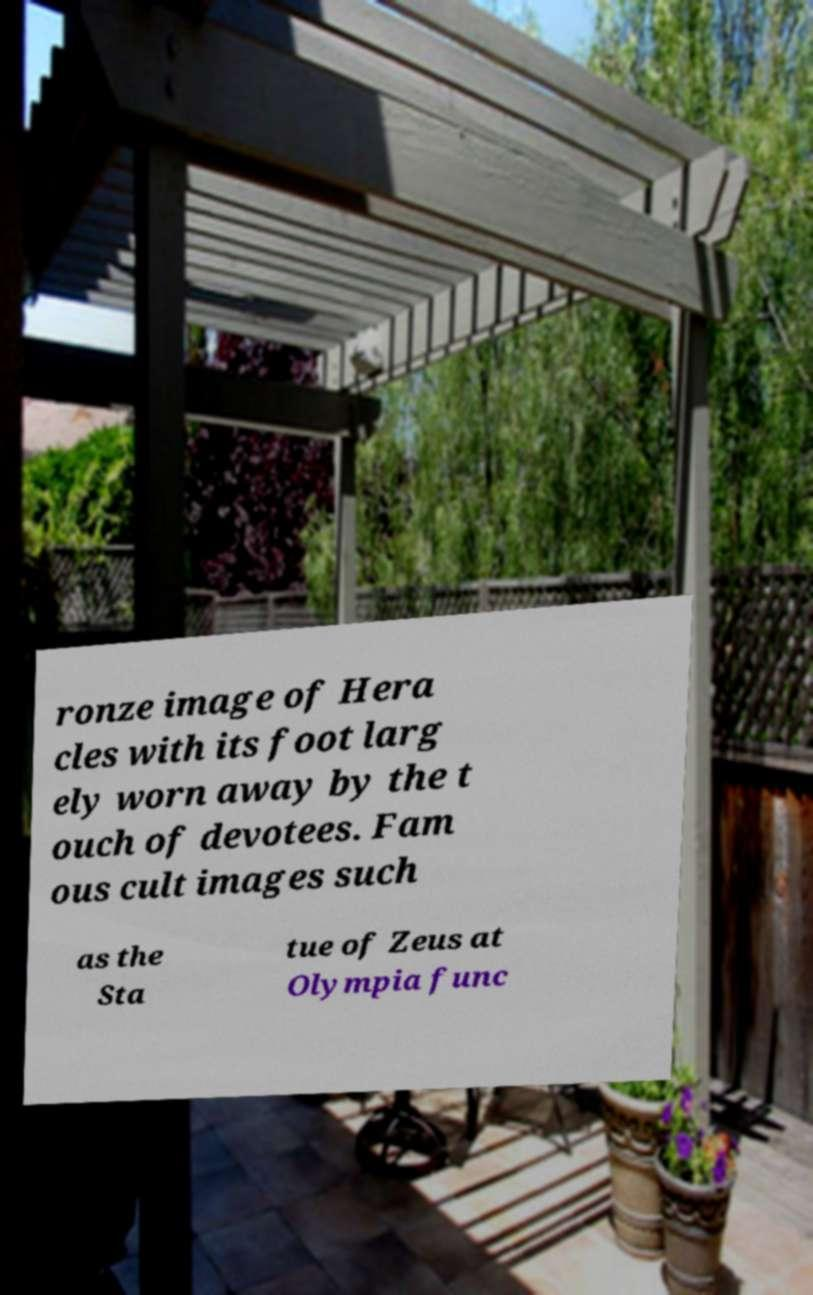Can you accurately transcribe the text from the provided image for me? ronze image of Hera cles with its foot larg ely worn away by the t ouch of devotees. Fam ous cult images such as the Sta tue of Zeus at Olympia func 